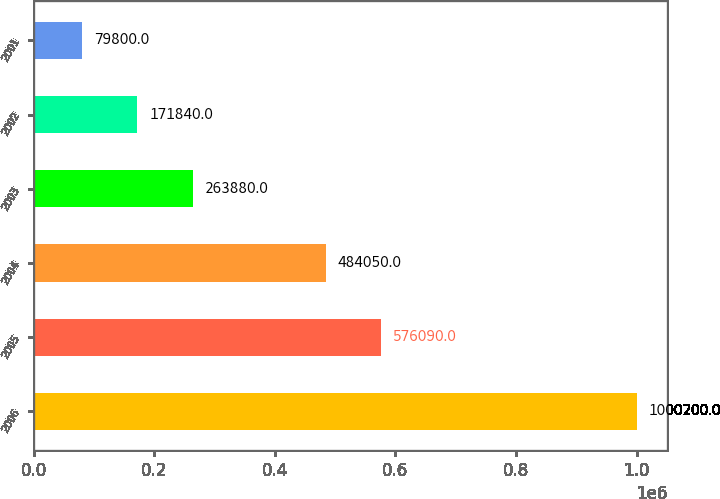Convert chart to OTSL. <chart><loc_0><loc_0><loc_500><loc_500><bar_chart><fcel>2006<fcel>2005<fcel>2004<fcel>2003<fcel>2002<fcel>2001<nl><fcel>1.0002e+06<fcel>576090<fcel>484050<fcel>263880<fcel>171840<fcel>79800<nl></chart> 